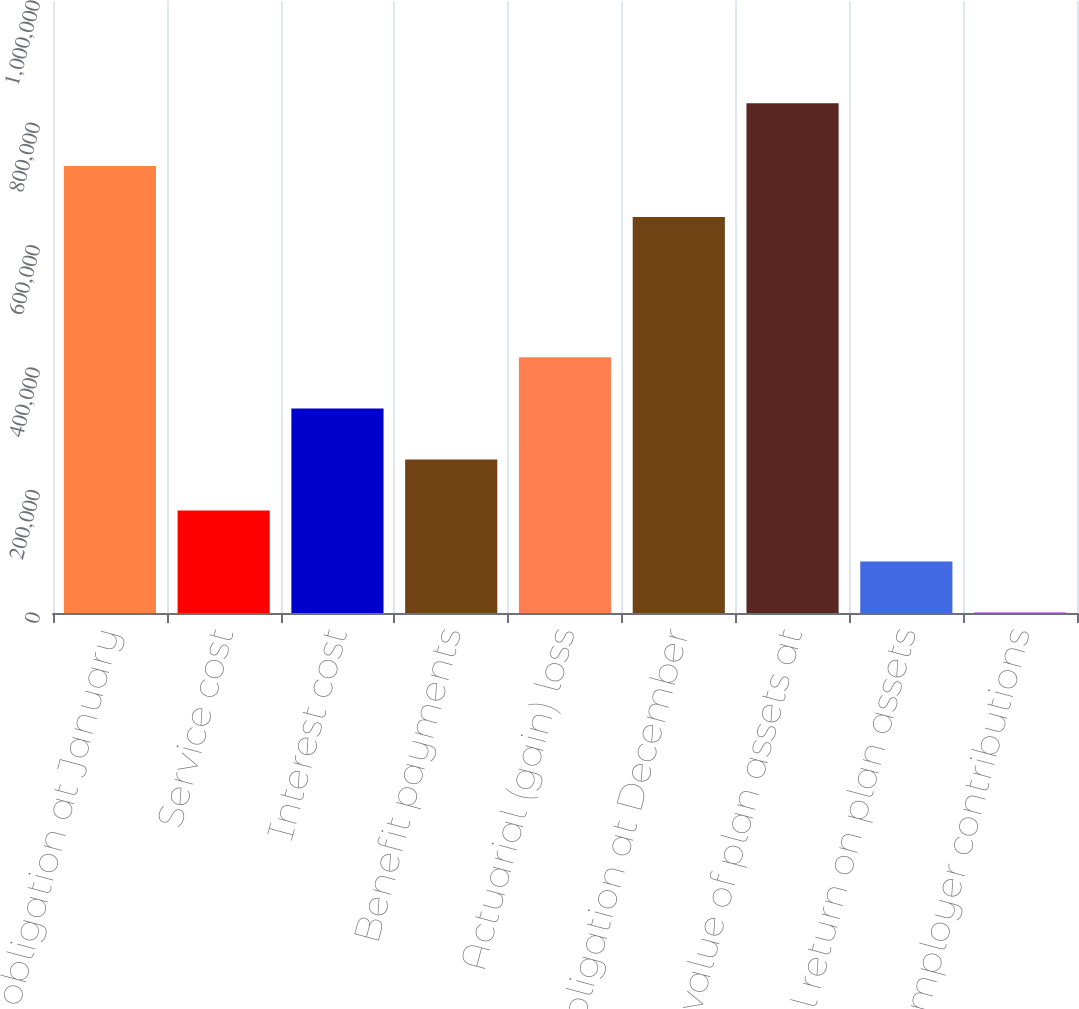<chart> <loc_0><loc_0><loc_500><loc_500><bar_chart><fcel>Benefit obligation at January<fcel>Service cost<fcel>Interest cost<fcel>Benefit payments<fcel>Actuarial (gain) loss<fcel>Benefit obligation at December<fcel>Fair value of plan assets at<fcel>Actual return on plan assets<fcel>Employer contributions<nl><fcel>730403<fcel>167558<fcel>334325<fcel>250941<fcel>417708<fcel>647020<fcel>833017<fcel>84174.4<fcel>791<nl></chart> 